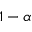<formula> <loc_0><loc_0><loc_500><loc_500>1 - \alpha</formula> 